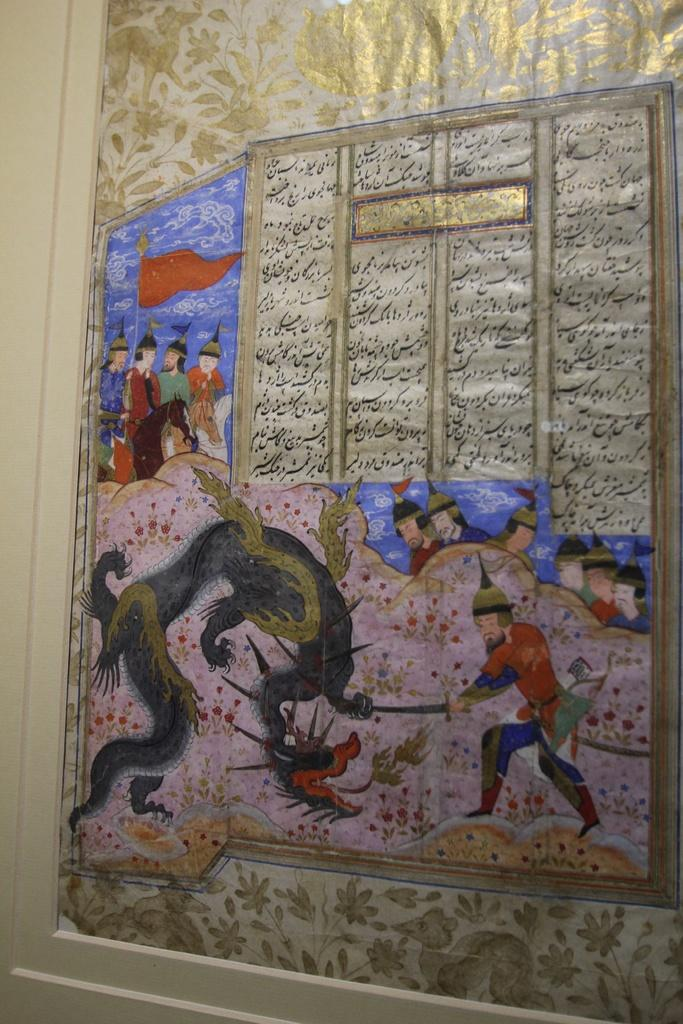What is the main subject of the image? The main subject of the image is a painting. What is depicted in the painting? The painting depicts persons and an animal. Where is the painting located in the image? The painting is on a door. What type of loaf is being used to support the painting on the door? There is no loaf present in the image; the painting is simply on the door. 